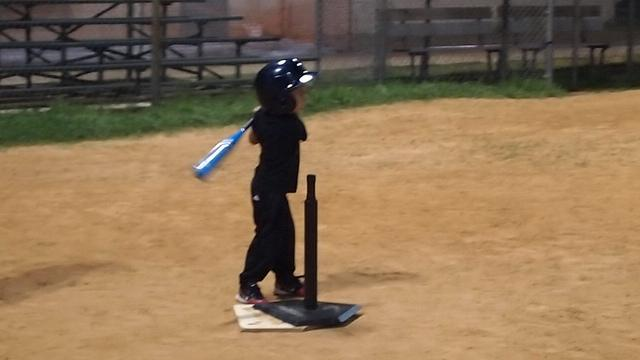Who would the child be more likely to admire?

Choices:
A) pete alonso
B) pele
C) wayne gretzky
D) tiger woods pete alonso 